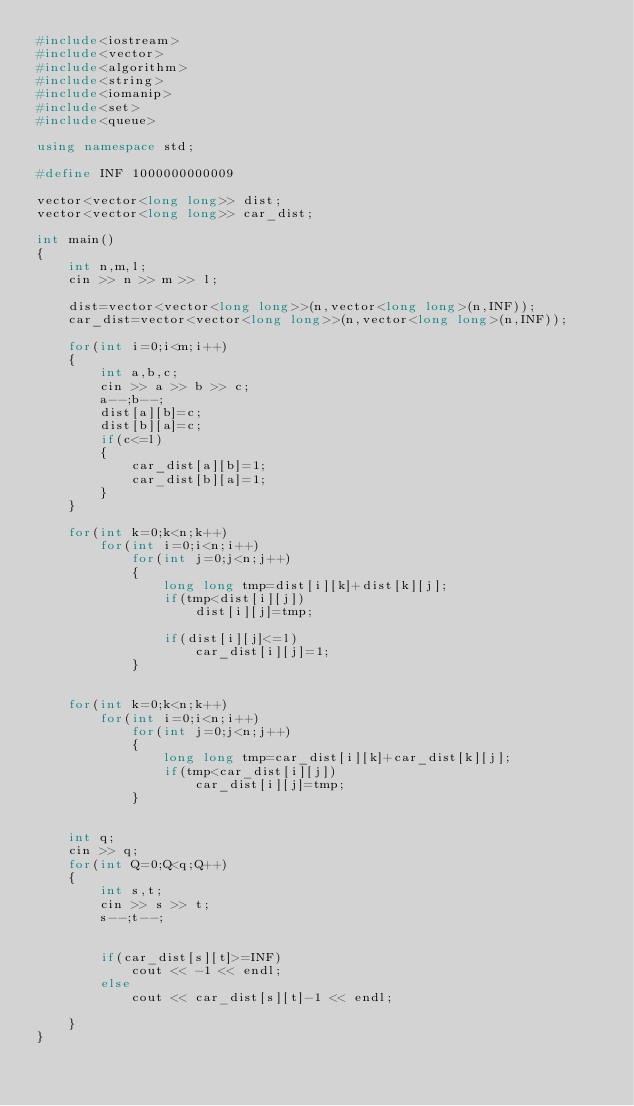Convert code to text. <code><loc_0><loc_0><loc_500><loc_500><_C++_>#include<iostream>
#include<vector>
#include<algorithm>
#include<string>
#include<iomanip>
#include<set>
#include<queue>

using namespace std;

#define INF 1000000000009

vector<vector<long long>> dist;
vector<vector<long long>> car_dist;

int main()
{
	int n,m,l;
	cin >> n >> m >> l;

	dist=vector<vector<long long>>(n,vector<long long>(n,INF));
	car_dist=vector<vector<long long>>(n,vector<long long>(n,INF));

	for(int i=0;i<m;i++)
	{
		int a,b,c;
		cin >> a >> b >> c;
		a--;b--;
		dist[a][b]=c;
		dist[b][a]=c;
		if(c<=l)
		{
			car_dist[a][b]=1;
			car_dist[b][a]=1;
		}
	}

	for(int k=0;k<n;k++)
		for(int i=0;i<n;i++)
			for(int j=0;j<n;j++)
			{
				long long tmp=dist[i][k]+dist[k][j];
				if(tmp<dist[i][j])
					dist[i][j]=tmp;

				if(dist[i][j]<=l)
					car_dist[i][j]=1;
			}
	
	
	for(int k=0;k<n;k++)
		for(int i=0;i<n;i++)
			for(int j=0;j<n;j++)
			{
				long long tmp=car_dist[i][k]+car_dist[k][j];
				if(tmp<car_dist[i][j])
					car_dist[i][j]=tmp;
			}
	
		
	int q;
	cin >> q;
	for(int Q=0;Q<q;Q++)
	{
		int s,t;
		cin >> s >> t;
		s--;t--;


		if(car_dist[s][t]>=INF)
			cout << -1 << endl;
		else
			cout << car_dist[s][t]-1 << endl;

	}
}
</code> 